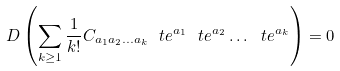<formula> <loc_0><loc_0><loc_500><loc_500>D \left ( \sum _ { k \geq 1 } \frac { 1 } { k ! } C _ { a _ { 1 } a _ { 2 } \dots a _ { k } } \ t e ^ { a _ { 1 } } \ t e ^ { a _ { 2 } } \dots \ t e ^ { a _ { k } } \right ) = 0</formula> 